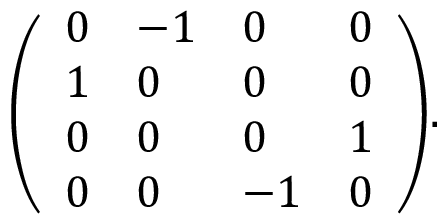<formula> <loc_0><loc_0><loc_500><loc_500>{ \left ( \begin{array} { l l l l } { 0 } & { - 1 } & { 0 } & { 0 } \\ { 1 } & { 0 } & { 0 } & { 0 } \\ { 0 } & { 0 } & { 0 } & { 1 } \\ { 0 } & { 0 } & { - 1 } & { 0 } \end{array} \right ) } .</formula> 